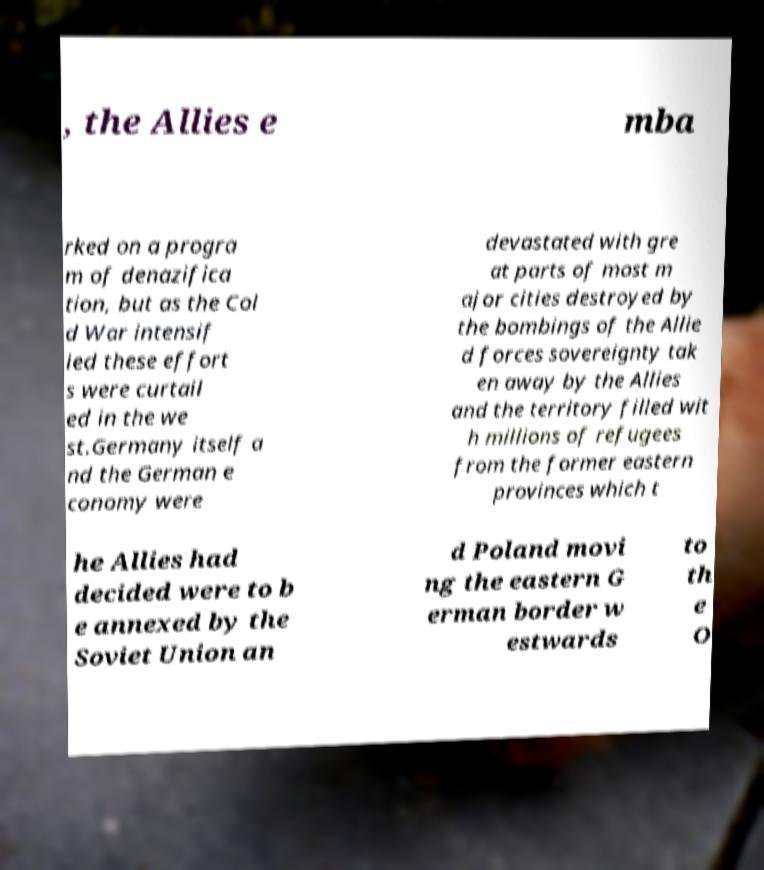Can you read and provide the text displayed in the image?This photo seems to have some interesting text. Can you extract and type it out for me? , the Allies e mba rked on a progra m of denazifica tion, but as the Col d War intensif ied these effort s were curtail ed in the we st.Germany itself a nd the German e conomy were devastated with gre at parts of most m ajor cities destroyed by the bombings of the Allie d forces sovereignty tak en away by the Allies and the territory filled wit h millions of refugees from the former eastern provinces which t he Allies had decided were to b e annexed by the Soviet Union an d Poland movi ng the eastern G erman border w estwards to th e O 